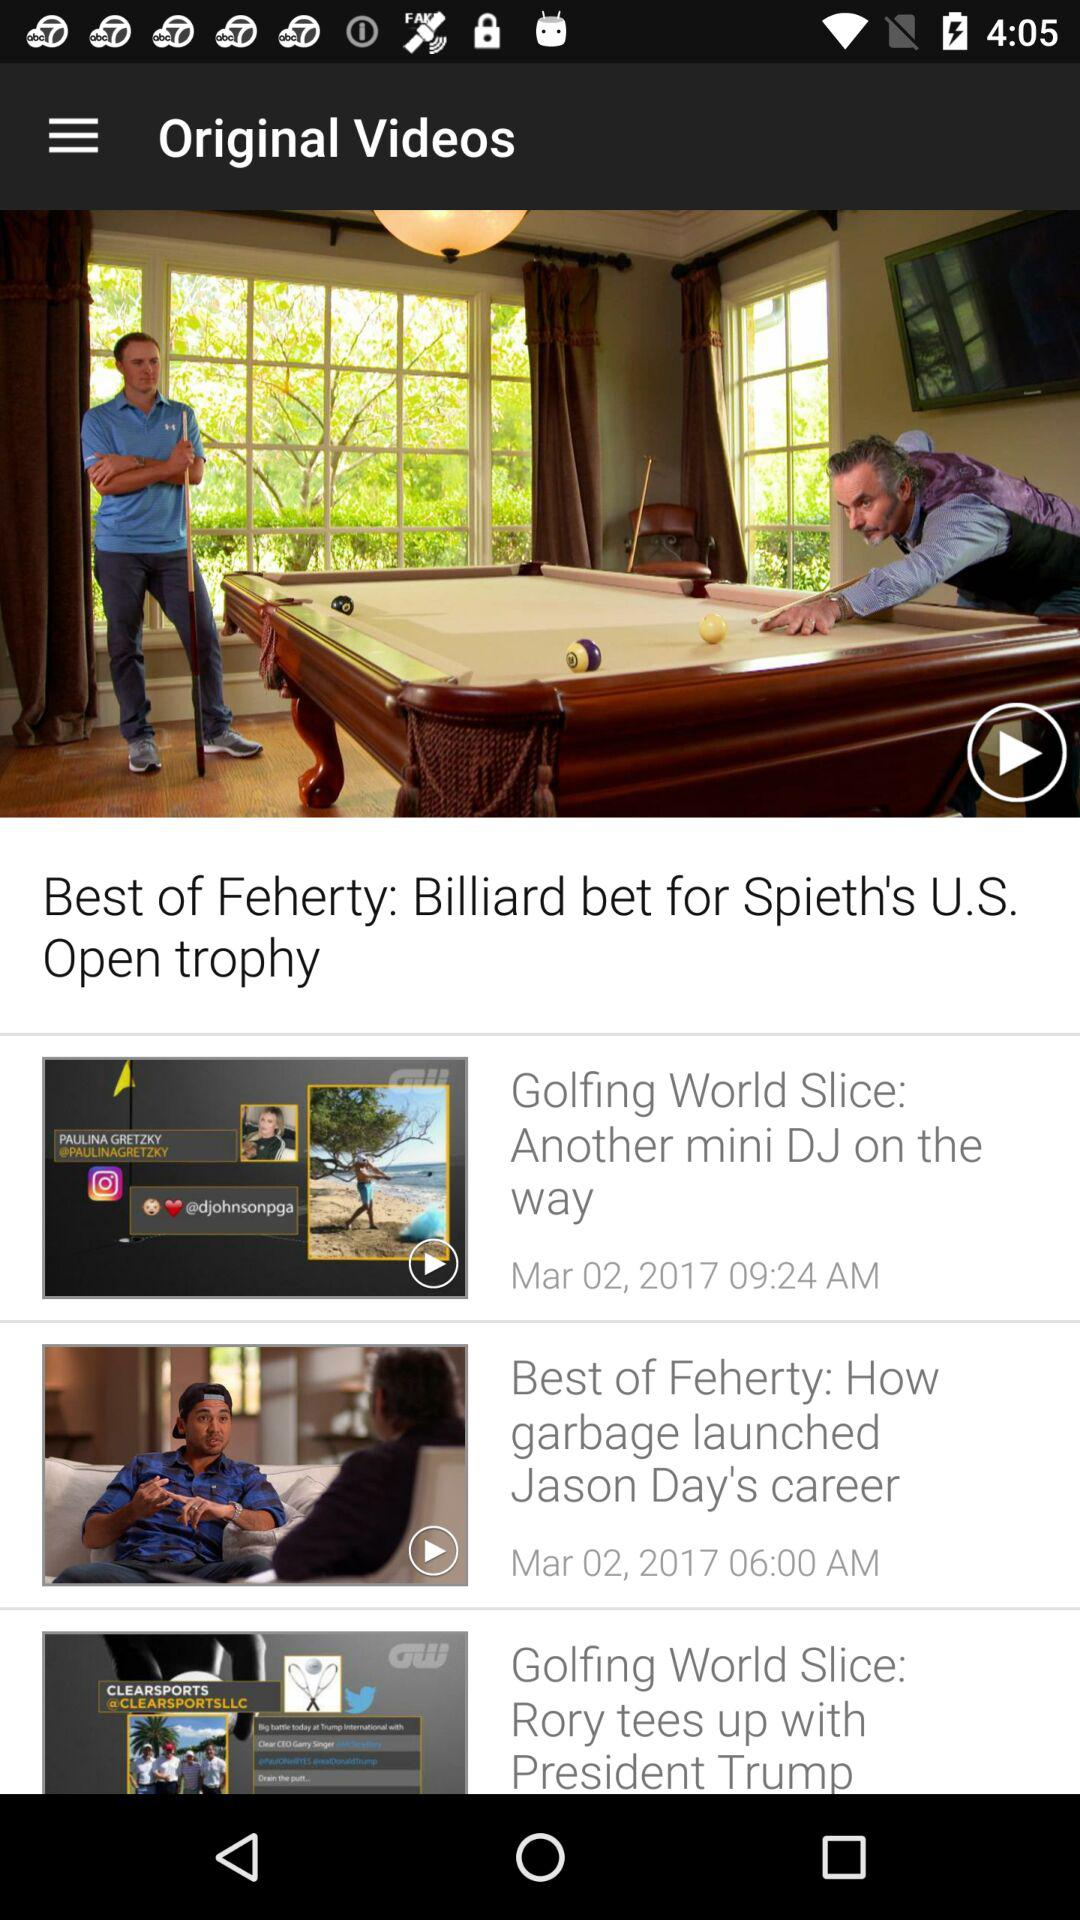Who posted "Best of Feherty: Billiard bet for Spieth's U.S. Open trophy"?
When the provided information is insufficient, respond with <no answer>. <no answer> 